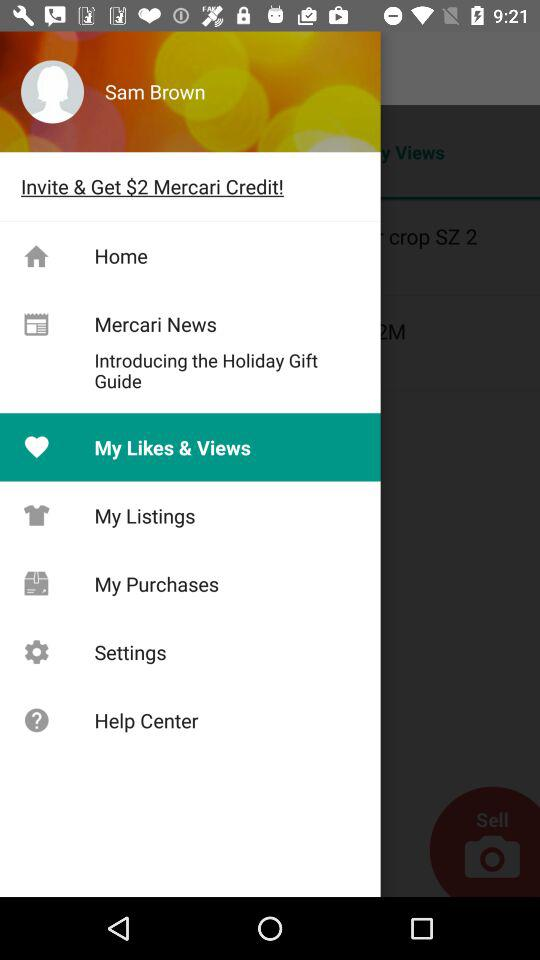Which tab is selected? The selected tab is "My Likes & Views". 